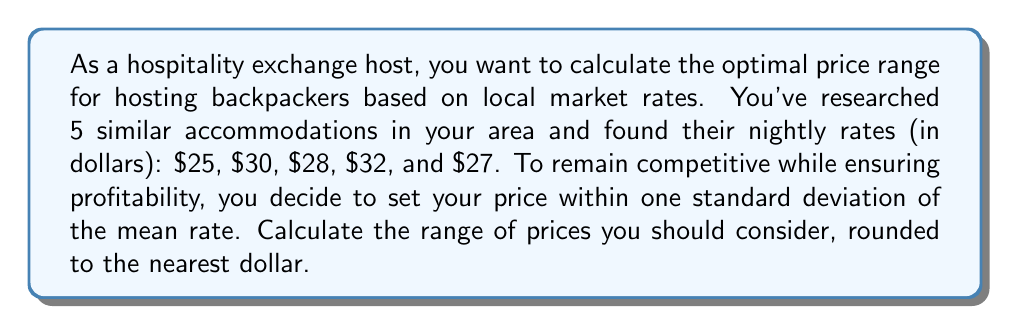Teach me how to tackle this problem. To solve this problem, we need to follow these steps:

1. Calculate the mean of the given rates.
2. Calculate the standard deviation of the rates.
3. Determine the price range using the mean ± one standard deviation.

Step 1: Calculate the mean
$$ \text{Mean} = \frac{\sum_{i=1}^{n} x_i}{n} = \frac{25 + 30 + 28 + 32 + 27}{5} = \frac{142}{5} = 28.4 $$

Step 2: Calculate the standard deviation
First, we need to calculate the variance:

$$ \text{Variance} = \frac{\sum_{i=1}^{n} (x_i - \text{Mean})^2}{n-1} $$

$$ = \frac{(25-28.4)^2 + (30-28.4)^2 + (28-28.4)^2 + (32-28.4)^2 + (27-28.4)^2}{5-1} $$
$$ = \frac{(-3.4)^2 + (1.6)^2 + (-0.4)^2 + (3.6)^2 + (-1.4)^2}{4} $$
$$ = \frac{11.56 + 2.56 + 0.16 + 12.96 + 1.96}{4} = \frac{29.2}{4} = 7.3 $$

Now, we can calculate the standard deviation:

$$ \text{Standard Deviation} = \sqrt{\text{Variance}} = \sqrt{7.3} \approx 2.7 $$

Step 3: Determine the price range
Lower bound: $$ 28.4 - 2.7 = 25.7 $$
Upper bound: $$ 28.4 + 2.7 = 31.1 $$

Rounding to the nearest dollar:
Lower bound: $26
Upper bound: $31
Answer: The optimal price range for hosting, based on local market rates and rounded to the nearest dollar, is $26 to $31 per night. 